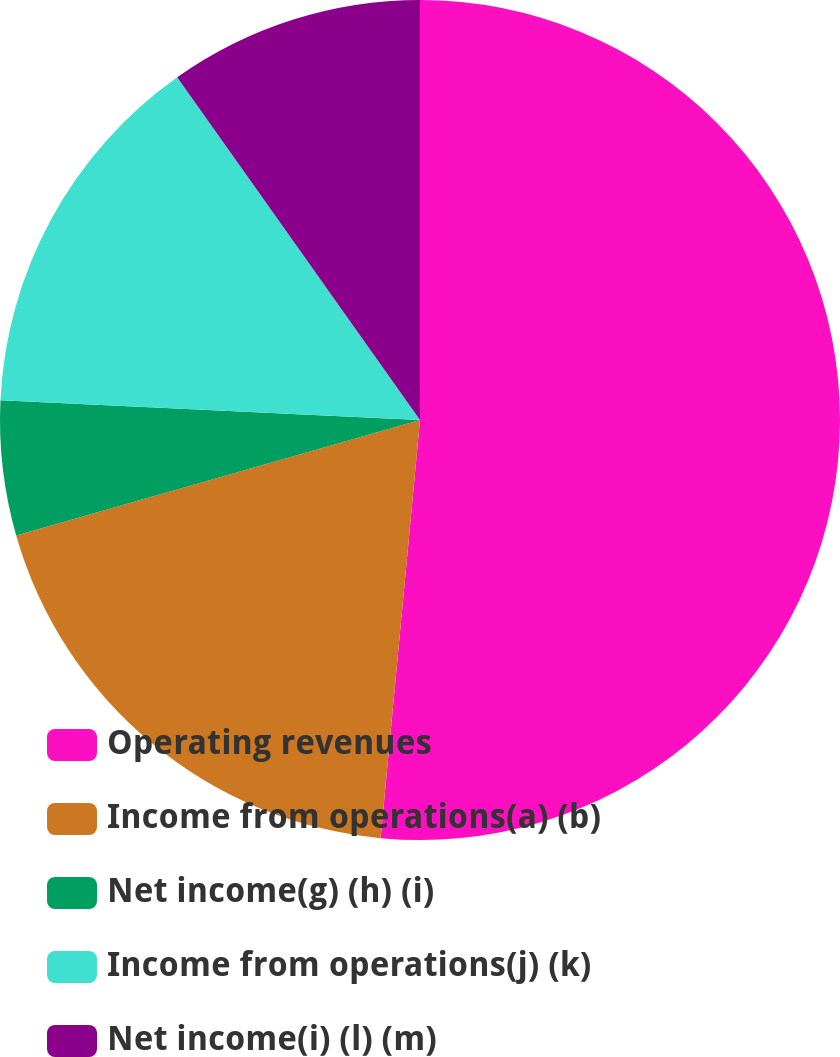Convert chart. <chart><loc_0><loc_0><loc_500><loc_500><pie_chart><fcel>Operating revenues<fcel>Income from operations(a) (b)<fcel>Net income(g) (h) (i)<fcel>Income from operations(j) (k)<fcel>Net income(i) (l) (m)<nl><fcel>51.49%<fcel>19.07%<fcel>5.18%<fcel>14.44%<fcel>9.81%<nl></chart> 